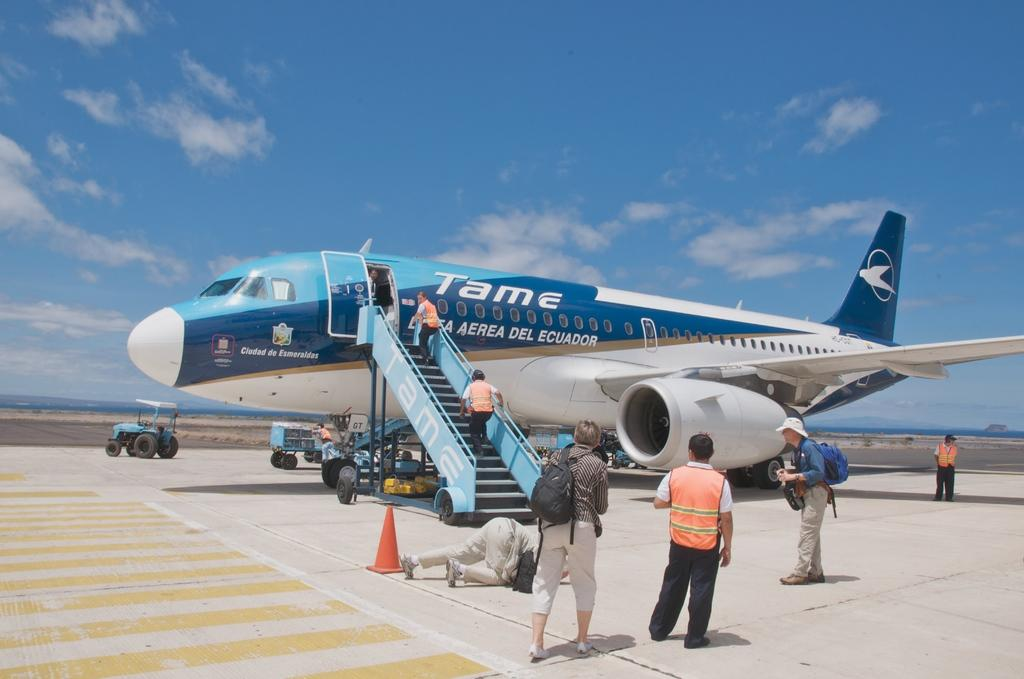Provide a one-sentence caption for the provided image. The Tame airplane has its steps down for boarding. 